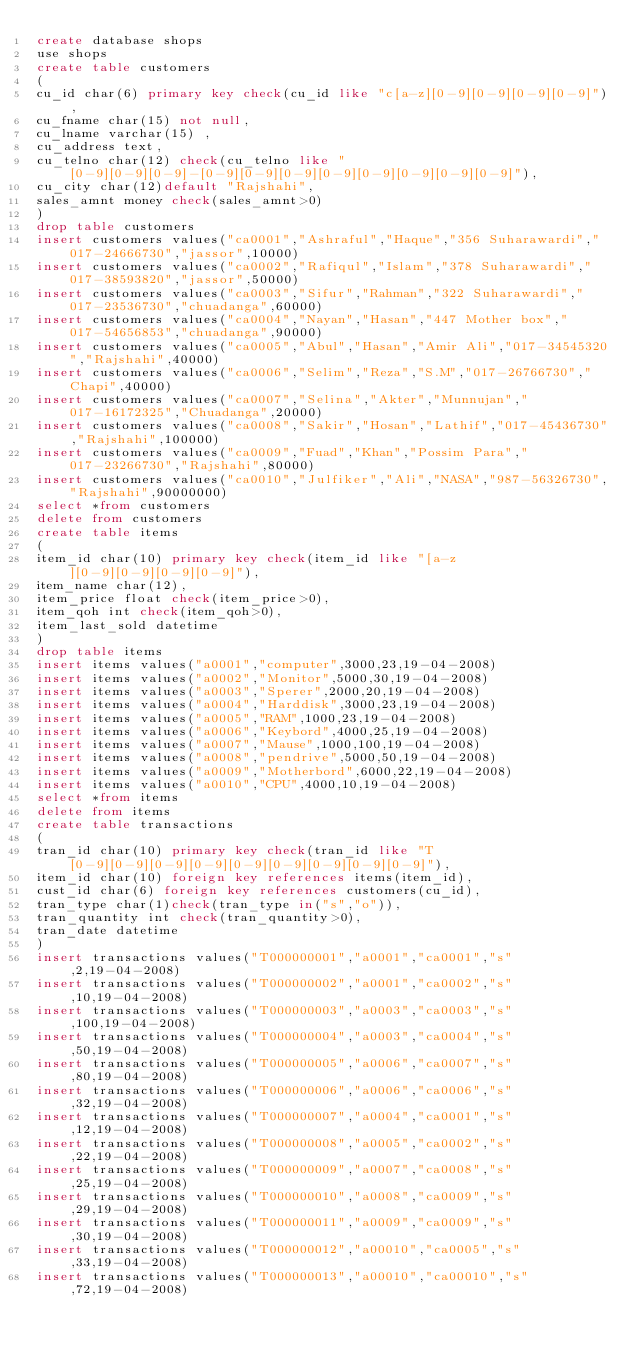<code> <loc_0><loc_0><loc_500><loc_500><_SQL_>create database shops
use shops
create table customers
(
cu_id char(6) primary key check(cu_id like "c[a-z][0-9][0-9][0-9][0-9]"),
cu_fname char(15) not null,
cu_lname varchar(15) ,
cu_address text,
cu_telno char(12) check(cu_telno like "[0-9][0-9][0-9]-[0-9][0-9][0-9][0-9][0-9][0-9][0-9][0-9]"),
cu_city char(12)default "Rajshahi",
sales_amnt money check(sales_amnt>0)
)
drop table customers
insert customers values("ca0001","Ashraful","Haque","356 Suharawardi","017-24666730","jassor",10000)
insert customers values("ca0002","Rafiqul","Islam","378 Suharawardi","017-38593820","jassor",50000)
insert customers values("ca0003","Sifur","Rahman","322 Suharawardi","017-23536730","chuadanga",60000)
insert customers values("ca0004","Nayan","Hasan","447 Mother box","017-54656853","chuadanga",90000)
insert customers values("ca0005","Abul","Hasan","Amir Ali","017-34545320","Rajshahi",40000)
insert customers values("ca0006","Selim","Reza","S.M","017-26766730","Chapi",40000)
insert customers values("ca0007","Selina","Akter","Munnujan","017-16172325","Chuadanga",20000)
insert customers values("ca0008","Sakir","Hosan","Lathif","017-45436730","Rajshahi",100000)
insert customers values("ca0009","Fuad","Khan","Possim Para","017-23266730","Rajshahi",80000)
insert customers values("ca0010","Julfiker","Ali","NASA","987-56326730","Rajshahi",90000000)
select *from customers
delete from customers
create table items
(
item_id char(10) primary key check(item_id like "[a-z][0-9][0-9][0-9][0-9]"),
item_name char(12),
item_price float check(item_price>0),
item_qoh int check(item_qoh>0),
item_last_sold datetime
)
drop table items
insert items values("a0001","computer",3000,23,19-04-2008)
insert items values("a0002","Monitor",5000,30,19-04-2008)
insert items values("a0003","Sperer",2000,20,19-04-2008)
insert items values("a0004","Harddisk",3000,23,19-04-2008)
insert items values("a0005","RAM",1000,23,19-04-2008)
insert items values("a0006","Keybord",4000,25,19-04-2008)
insert items values("a0007","Mause",1000,100,19-04-2008)
insert items values("a0008","pendrive",5000,50,19-04-2008)
insert items values("a0009","Motherbord",6000,22,19-04-2008)
insert items values("a0010","CPU",4000,10,19-04-2008)
select *from items
delete from items
create table transactions
(
tran_id char(10) primary key check(tran_id like "T[0-9][0-9][0-9][0-9][0-9][0-9][0-9][0-9][0-9]"),
item_id char(10) foreign key references items(item_id),
cust_id char(6) foreign key references customers(cu_id),
tran_type char(1)check(tran_type in("s","o")),
tran_quantity int check(tran_quantity>0),
tran_date datetime
)
insert transactions values("T000000001","a0001","ca0001","s",2,19-04-2008)
insert transactions values("T000000002","a0001","ca0002","s",10,19-04-2008)
insert transactions values("T000000003","a0003","ca0003","s",100,19-04-2008)
insert transactions values("T000000004","a0003","ca0004","s",50,19-04-2008)
insert transactions values("T000000005","a0006","ca0007","s",80,19-04-2008)
insert transactions values("T000000006","a0006","ca0006","s",32,19-04-2008)
insert transactions values("T000000007","a0004","ca0001","s",12,19-04-2008)
insert transactions values("T000000008","a0005","ca0002","s",22,19-04-2008)
insert transactions values("T000000009","a0007","ca0008","s",25,19-04-2008)
insert transactions values("T000000010","a0008","ca0009","s",29,19-04-2008)
insert transactions values("T000000011","a0009","ca0009","s",30,19-04-2008)
insert transactions values("T000000012","a00010","ca0005","s",33,19-04-2008)
insert transactions values("T000000013","a00010","ca00010","s",72,19-04-2008)</code> 